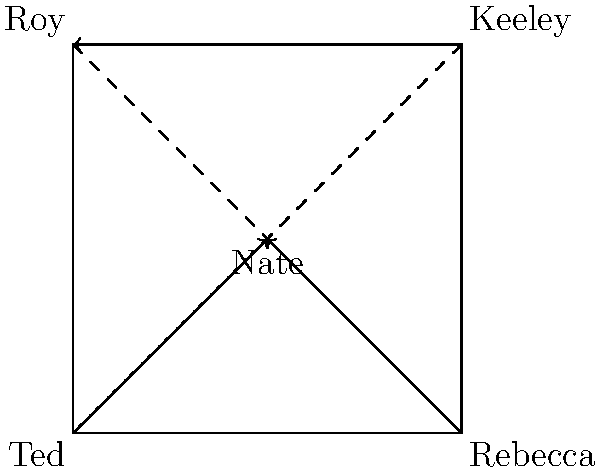In this origami representation of character relationships in "Ted Lasso," if the paper is folded along both diagonal lines simultaneously, which character's position would overlap with Nate's? To solve this mental folding task, let's follow these steps:

1. Visualize the square paper with the characters at each corner and Nate in the center.
2. Imagine folding along both diagonal lines (Ted to Keeley and Rebecca to Roy) simultaneously.
3. This fold would bring all four corners to the center point where Nate is positioned.
4. As all corners meet at the center, all four characters (Ted, Rebecca, Keeley, and Roy) would overlap with Nate's position.
5. However, the question asks for a single character, so we need to consider which character's development is most closely tied to Nate's throughout the series.
6. Nate's character arc is significantly influenced by his relationship with Ted, starting as the kit man, becoming a coach, and eventually leaving to join a rival team.

Therefore, while all characters would technically overlap with Nate's position, Ted's relationship with Nate is the most significant in terms of character development and story arc.
Answer: Ted 